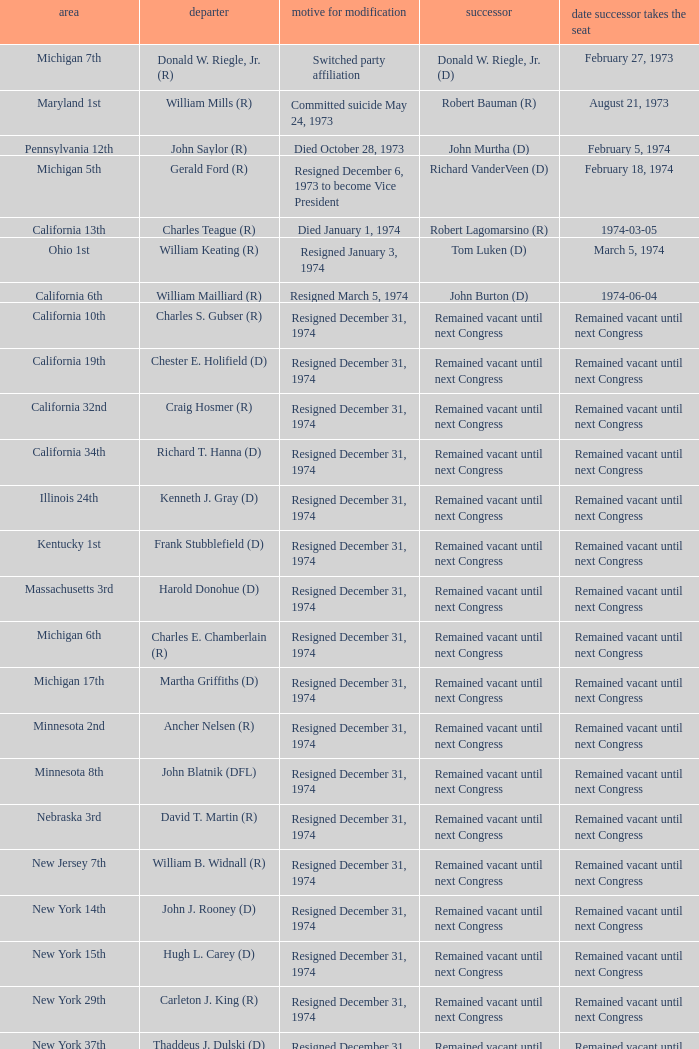Who was the successor when the vacator was chester e. holifield (d)? Remained vacant until next Congress. 